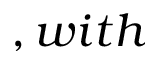Convert formula to latex. <formula><loc_0><loc_0><loc_500><loc_500>, w i t h</formula> 